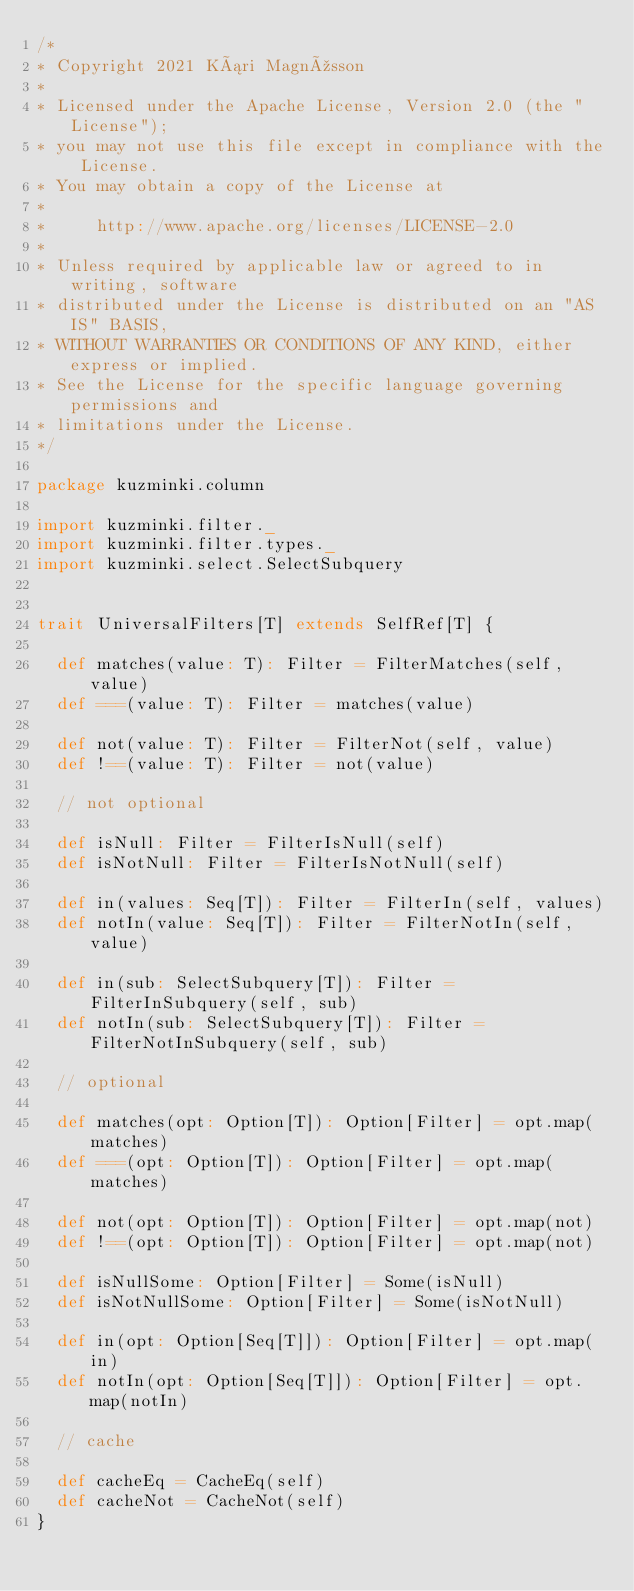Convert code to text. <code><loc_0><loc_0><loc_500><loc_500><_Scala_>/*
* Copyright 2021 Kári Magnússon
*
* Licensed under the Apache License, Version 2.0 (the "License");
* you may not use this file except in compliance with the License.
* You may obtain a copy of the License at
*
*     http://www.apache.org/licenses/LICENSE-2.0
*
* Unless required by applicable law or agreed to in writing, software
* distributed under the License is distributed on an "AS IS" BASIS,
* WITHOUT WARRANTIES OR CONDITIONS OF ANY KIND, either express or implied.
* See the License for the specific language governing permissions and
* limitations under the License.
*/

package kuzminki.column

import kuzminki.filter._
import kuzminki.filter.types._
import kuzminki.select.SelectSubquery


trait UniversalFilters[T] extends SelfRef[T] {
  
  def matches(value: T): Filter = FilterMatches(self, value)
  def ===(value: T): Filter = matches(value)

  def not(value: T): Filter = FilterNot(self, value)
  def !==(value: T): Filter = not(value)
  
  // not optional

  def isNull: Filter = FilterIsNull(self)
  def isNotNull: Filter = FilterIsNotNull(self)

  def in(values: Seq[T]): Filter = FilterIn(self, values)
  def notIn(value: Seq[T]): Filter = FilterNotIn(self, value)

  def in(sub: SelectSubquery[T]): Filter = FilterInSubquery(self, sub)
  def notIn(sub: SelectSubquery[T]): Filter = FilterNotInSubquery(self, sub)

  // optional

  def matches(opt: Option[T]): Option[Filter] = opt.map(matches)
  def ===(opt: Option[T]): Option[Filter] = opt.map(matches)

  def not(opt: Option[T]): Option[Filter] = opt.map(not)
  def !==(opt: Option[T]): Option[Filter] = opt.map(not)

  def isNullSome: Option[Filter] = Some(isNull)
  def isNotNullSome: Option[Filter] = Some(isNotNull)

  def in(opt: Option[Seq[T]]): Option[Filter] = opt.map(in)
  def notIn(opt: Option[Seq[T]]): Option[Filter] = opt.map(notIn)

  // cache

  def cacheEq = CacheEq(self)
  def cacheNot = CacheNot(self)
}






















</code> 